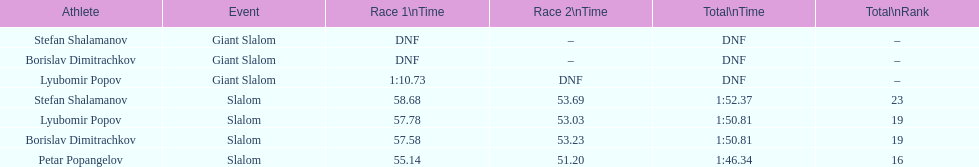What is the rank number of stefan shalamanov in the slalom event 23. 